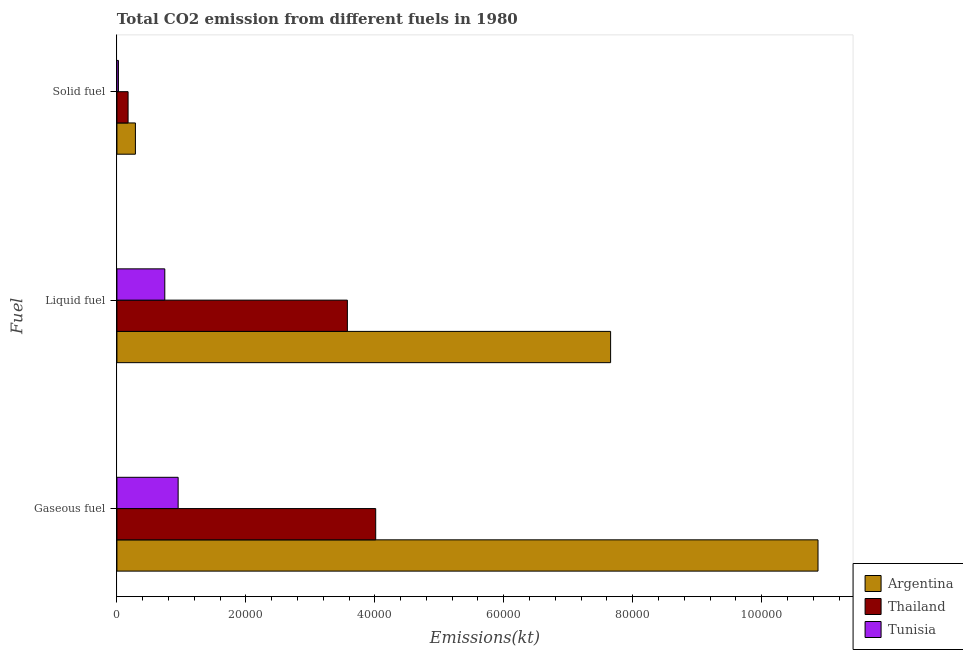How many different coloured bars are there?
Provide a succinct answer. 3. Are the number of bars on each tick of the Y-axis equal?
Make the answer very short. Yes. How many bars are there on the 3rd tick from the top?
Ensure brevity in your answer.  3. What is the label of the 3rd group of bars from the top?
Provide a short and direct response. Gaseous fuel. What is the amount of co2 emissions from liquid fuel in Tunisia?
Provide a succinct answer. 7425.68. Across all countries, what is the maximum amount of co2 emissions from gaseous fuel?
Offer a very short reply. 1.09e+05. Across all countries, what is the minimum amount of co2 emissions from solid fuel?
Make the answer very short. 234.69. In which country was the amount of co2 emissions from liquid fuel minimum?
Your answer should be very brief. Tunisia. What is the total amount of co2 emissions from solid fuel in the graph?
Provide a short and direct response. 4833.11. What is the difference between the amount of co2 emissions from gaseous fuel in Thailand and that in Argentina?
Give a very brief answer. -6.86e+04. What is the difference between the amount of co2 emissions from liquid fuel in Tunisia and the amount of co2 emissions from gaseous fuel in Thailand?
Ensure brevity in your answer.  -3.27e+04. What is the average amount of co2 emissions from liquid fuel per country?
Make the answer very short. 3.99e+04. What is the difference between the amount of co2 emissions from gaseous fuel and amount of co2 emissions from liquid fuel in Argentina?
Provide a short and direct response. 3.22e+04. In how many countries, is the amount of co2 emissions from solid fuel greater than 84000 kt?
Keep it short and to the point. 0. What is the ratio of the amount of co2 emissions from solid fuel in Tunisia to that in Thailand?
Your answer should be compact. 0.14. Is the difference between the amount of co2 emissions from gaseous fuel in Argentina and Thailand greater than the difference between the amount of co2 emissions from solid fuel in Argentina and Thailand?
Provide a short and direct response. Yes. What is the difference between the highest and the second highest amount of co2 emissions from solid fuel?
Offer a very short reply. 1136.77. What is the difference between the highest and the lowest amount of co2 emissions from gaseous fuel?
Keep it short and to the point. 9.92e+04. Is the sum of the amount of co2 emissions from solid fuel in Argentina and Tunisia greater than the maximum amount of co2 emissions from liquid fuel across all countries?
Make the answer very short. No. What does the 2nd bar from the top in Liquid fuel represents?
Make the answer very short. Thailand. What does the 1st bar from the bottom in Gaseous fuel represents?
Keep it short and to the point. Argentina. How many bars are there?
Your answer should be compact. 9. Are all the bars in the graph horizontal?
Provide a short and direct response. Yes. How many countries are there in the graph?
Keep it short and to the point. 3. What is the difference between two consecutive major ticks on the X-axis?
Ensure brevity in your answer.  2.00e+04. Does the graph contain grids?
Offer a terse response. No. Where does the legend appear in the graph?
Your response must be concise. Bottom right. What is the title of the graph?
Your answer should be compact. Total CO2 emission from different fuels in 1980. What is the label or title of the X-axis?
Provide a succinct answer. Emissions(kt). What is the label or title of the Y-axis?
Ensure brevity in your answer.  Fuel. What is the Emissions(kt) of Argentina in Gaseous fuel?
Your answer should be compact. 1.09e+05. What is the Emissions(kt) of Thailand in Gaseous fuel?
Offer a very short reply. 4.01e+04. What is the Emissions(kt) of Tunisia in Gaseous fuel?
Offer a terse response. 9493.86. What is the Emissions(kt) of Argentina in Liquid fuel?
Give a very brief answer. 7.66e+04. What is the Emissions(kt) of Thailand in Liquid fuel?
Ensure brevity in your answer.  3.57e+04. What is the Emissions(kt) of Tunisia in Liquid fuel?
Offer a terse response. 7425.68. What is the Emissions(kt) in Argentina in Solid fuel?
Provide a succinct answer. 2867.59. What is the Emissions(kt) in Thailand in Solid fuel?
Offer a very short reply. 1730.82. What is the Emissions(kt) in Tunisia in Solid fuel?
Give a very brief answer. 234.69. Across all Fuel, what is the maximum Emissions(kt) of Argentina?
Keep it short and to the point. 1.09e+05. Across all Fuel, what is the maximum Emissions(kt) of Thailand?
Offer a terse response. 4.01e+04. Across all Fuel, what is the maximum Emissions(kt) of Tunisia?
Ensure brevity in your answer.  9493.86. Across all Fuel, what is the minimum Emissions(kt) of Argentina?
Provide a succinct answer. 2867.59. Across all Fuel, what is the minimum Emissions(kt) of Thailand?
Provide a succinct answer. 1730.82. Across all Fuel, what is the minimum Emissions(kt) in Tunisia?
Your response must be concise. 234.69. What is the total Emissions(kt) of Argentina in the graph?
Your response must be concise. 1.88e+05. What is the total Emissions(kt) of Thailand in the graph?
Offer a very short reply. 7.76e+04. What is the total Emissions(kt) of Tunisia in the graph?
Your answer should be very brief. 1.72e+04. What is the difference between the Emissions(kt) of Argentina in Gaseous fuel and that in Liquid fuel?
Keep it short and to the point. 3.22e+04. What is the difference between the Emissions(kt) of Thailand in Gaseous fuel and that in Liquid fuel?
Ensure brevity in your answer.  4393.07. What is the difference between the Emissions(kt) of Tunisia in Gaseous fuel and that in Liquid fuel?
Keep it short and to the point. 2068.19. What is the difference between the Emissions(kt) in Argentina in Gaseous fuel and that in Solid fuel?
Provide a succinct answer. 1.06e+05. What is the difference between the Emissions(kt) in Thailand in Gaseous fuel and that in Solid fuel?
Ensure brevity in your answer.  3.84e+04. What is the difference between the Emissions(kt) in Tunisia in Gaseous fuel and that in Solid fuel?
Provide a short and direct response. 9259.17. What is the difference between the Emissions(kt) in Argentina in Liquid fuel and that in Solid fuel?
Make the answer very short. 7.37e+04. What is the difference between the Emissions(kt) of Thailand in Liquid fuel and that in Solid fuel?
Your answer should be compact. 3.40e+04. What is the difference between the Emissions(kt) in Tunisia in Liquid fuel and that in Solid fuel?
Give a very brief answer. 7190.99. What is the difference between the Emissions(kt) of Argentina in Gaseous fuel and the Emissions(kt) of Thailand in Liquid fuel?
Make the answer very short. 7.30e+04. What is the difference between the Emissions(kt) in Argentina in Gaseous fuel and the Emissions(kt) in Tunisia in Liquid fuel?
Ensure brevity in your answer.  1.01e+05. What is the difference between the Emissions(kt) of Thailand in Gaseous fuel and the Emissions(kt) of Tunisia in Liquid fuel?
Keep it short and to the point. 3.27e+04. What is the difference between the Emissions(kt) in Argentina in Gaseous fuel and the Emissions(kt) in Thailand in Solid fuel?
Your answer should be compact. 1.07e+05. What is the difference between the Emissions(kt) of Argentina in Gaseous fuel and the Emissions(kt) of Tunisia in Solid fuel?
Provide a succinct answer. 1.09e+05. What is the difference between the Emissions(kt) of Thailand in Gaseous fuel and the Emissions(kt) of Tunisia in Solid fuel?
Provide a succinct answer. 3.99e+04. What is the difference between the Emissions(kt) in Argentina in Liquid fuel and the Emissions(kt) in Thailand in Solid fuel?
Your answer should be compact. 7.48e+04. What is the difference between the Emissions(kt) in Argentina in Liquid fuel and the Emissions(kt) in Tunisia in Solid fuel?
Your response must be concise. 7.63e+04. What is the difference between the Emissions(kt) of Thailand in Liquid fuel and the Emissions(kt) of Tunisia in Solid fuel?
Your response must be concise. 3.55e+04. What is the average Emissions(kt) in Argentina per Fuel?
Offer a very short reply. 6.27e+04. What is the average Emissions(kt) of Thailand per Fuel?
Provide a succinct answer. 2.59e+04. What is the average Emissions(kt) in Tunisia per Fuel?
Offer a very short reply. 5718.08. What is the difference between the Emissions(kt) in Argentina and Emissions(kt) in Thailand in Gaseous fuel?
Your response must be concise. 6.86e+04. What is the difference between the Emissions(kt) in Argentina and Emissions(kt) in Tunisia in Gaseous fuel?
Ensure brevity in your answer.  9.92e+04. What is the difference between the Emissions(kt) of Thailand and Emissions(kt) of Tunisia in Gaseous fuel?
Your response must be concise. 3.06e+04. What is the difference between the Emissions(kt) of Argentina and Emissions(kt) of Thailand in Liquid fuel?
Give a very brief answer. 4.08e+04. What is the difference between the Emissions(kt) of Argentina and Emissions(kt) of Tunisia in Liquid fuel?
Your response must be concise. 6.91e+04. What is the difference between the Emissions(kt) in Thailand and Emissions(kt) in Tunisia in Liquid fuel?
Provide a short and direct response. 2.83e+04. What is the difference between the Emissions(kt) of Argentina and Emissions(kt) of Thailand in Solid fuel?
Your answer should be compact. 1136.77. What is the difference between the Emissions(kt) in Argentina and Emissions(kt) in Tunisia in Solid fuel?
Your answer should be very brief. 2632.91. What is the difference between the Emissions(kt) of Thailand and Emissions(kt) of Tunisia in Solid fuel?
Your response must be concise. 1496.14. What is the ratio of the Emissions(kt) of Argentina in Gaseous fuel to that in Liquid fuel?
Offer a very short reply. 1.42. What is the ratio of the Emissions(kt) of Thailand in Gaseous fuel to that in Liquid fuel?
Provide a short and direct response. 1.12. What is the ratio of the Emissions(kt) of Tunisia in Gaseous fuel to that in Liquid fuel?
Your answer should be very brief. 1.28. What is the ratio of the Emissions(kt) of Argentina in Gaseous fuel to that in Solid fuel?
Your answer should be compact. 37.92. What is the ratio of the Emissions(kt) in Thailand in Gaseous fuel to that in Solid fuel?
Your answer should be compact. 23.19. What is the ratio of the Emissions(kt) in Tunisia in Gaseous fuel to that in Solid fuel?
Ensure brevity in your answer.  40.45. What is the ratio of the Emissions(kt) of Argentina in Liquid fuel to that in Solid fuel?
Your response must be concise. 26.7. What is the ratio of the Emissions(kt) of Thailand in Liquid fuel to that in Solid fuel?
Provide a short and direct response. 20.65. What is the ratio of the Emissions(kt) of Tunisia in Liquid fuel to that in Solid fuel?
Provide a short and direct response. 31.64. What is the difference between the highest and the second highest Emissions(kt) of Argentina?
Offer a very short reply. 3.22e+04. What is the difference between the highest and the second highest Emissions(kt) in Thailand?
Make the answer very short. 4393.07. What is the difference between the highest and the second highest Emissions(kt) of Tunisia?
Offer a very short reply. 2068.19. What is the difference between the highest and the lowest Emissions(kt) of Argentina?
Provide a short and direct response. 1.06e+05. What is the difference between the highest and the lowest Emissions(kt) in Thailand?
Make the answer very short. 3.84e+04. What is the difference between the highest and the lowest Emissions(kt) in Tunisia?
Keep it short and to the point. 9259.17. 